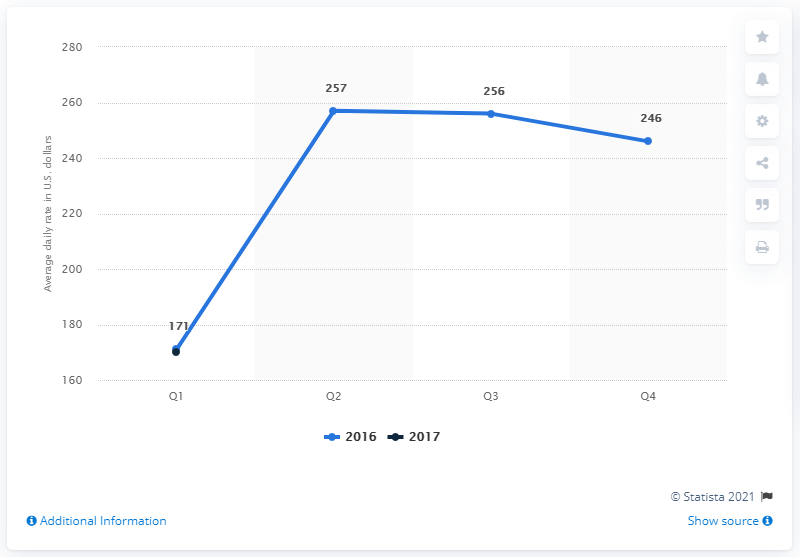List a handful of essential elements in this visual. In the first quarter of 2017, the average daily rate of hotels in Chicago, United States was approximately 170 U.S. dollars. 